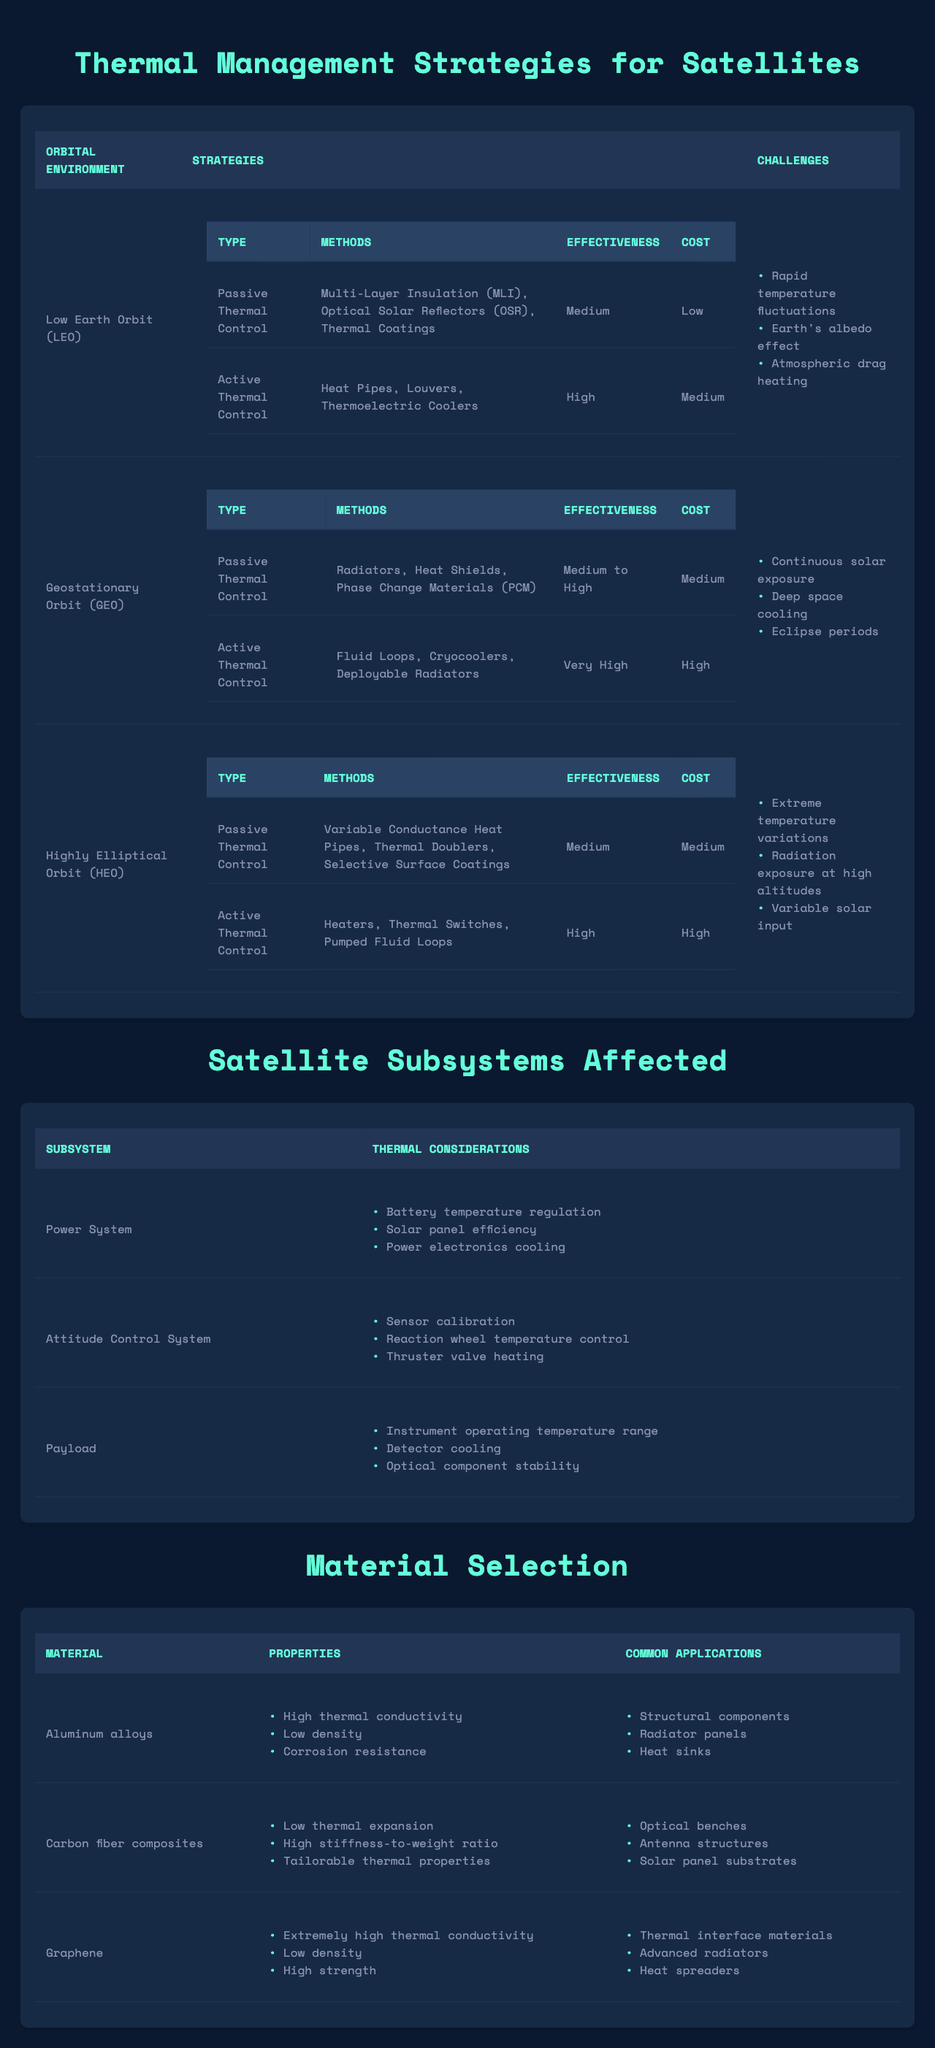What thermal control strategy has the highest effectiveness in Low Earth Orbit (LEO)? The table indicates that the Active Thermal Control strategy in LEO is rated as "High" for effectiveness, which is higher than the "Medium" rating for Passive Thermal Control.
Answer: Active Thermal Control What are the primary challenges faced in Geostationary Orbit (GEO)? The challenges listed in the table for GEO are continuous solar exposure, deep space cooling, and eclipse periods.
Answer: Continuous solar exposure, deep space cooling, eclipse periods Which thermal management strategy has the lowest cost in Highly Elliptical Orbit (HEO)? In HEO, the Passive Thermal Control strategy has a cost rating of "Medium" while Active Thermal Control has a cost rating of "High." Thus, Passive Thermal Control is the lowest cost strategy.
Answer: Passive Thermal Control Is the effectiveness of Passive Thermal Control in GEO rated as Medium? Yes, according to the table, the effectiveness of Passive Thermal Control in GEO is indeed rated as Medium to High.
Answer: Yes What is the material with extremely high thermal conductivity? The table indicates that Graphene is the material with extremely high thermal conductivity.
Answer: Graphene How many types of Active Thermal Control methods are listed for Low Earth Orbit? The table shows that there are three methods under Active Thermal Control for LEO: Heat Pipes, Louvers, and Thermoelectric Coolers.
Answer: Three methods Which thermal management strategy has the highest effectiveness overall across LEO, GEO, and HEO? Comparing effectiveness ratings, Active Thermal Control in GEO is rated as "Very High," higher than any rating in LEO and HEO. Therefore, Active Thermal Control in GEO has the highest effectiveness overall.
Answer: Active Thermal Control in GEO What are the common applications of Aluminum alloys listed in the table? The table lists three common applications for Aluminum alloys: Structural components, Radiator panels, and Heat sinks.
Answer: Structural components, Radiator panels, Heat sinks Are the thermal challenges in HEO related to extreme temperature variations? Yes, the table states that one of the challenges in HEO is extreme temperature variations, confirming that this fact is true.
Answer: Yes What is the average effectiveness rating of Passive Thermal Control across all orbital environments? The effectiveness ratings for Passive Thermal Control are Medium (LEO), Medium to High (GEO), and Medium (HEO). To average these, we can assign values: Medium = 2, Medium to High = 3. (2 + 3 + 2) / 3 = 2.33, which roughly corresponds to Medium. Therefore, the average is Medium.
Answer: Medium 